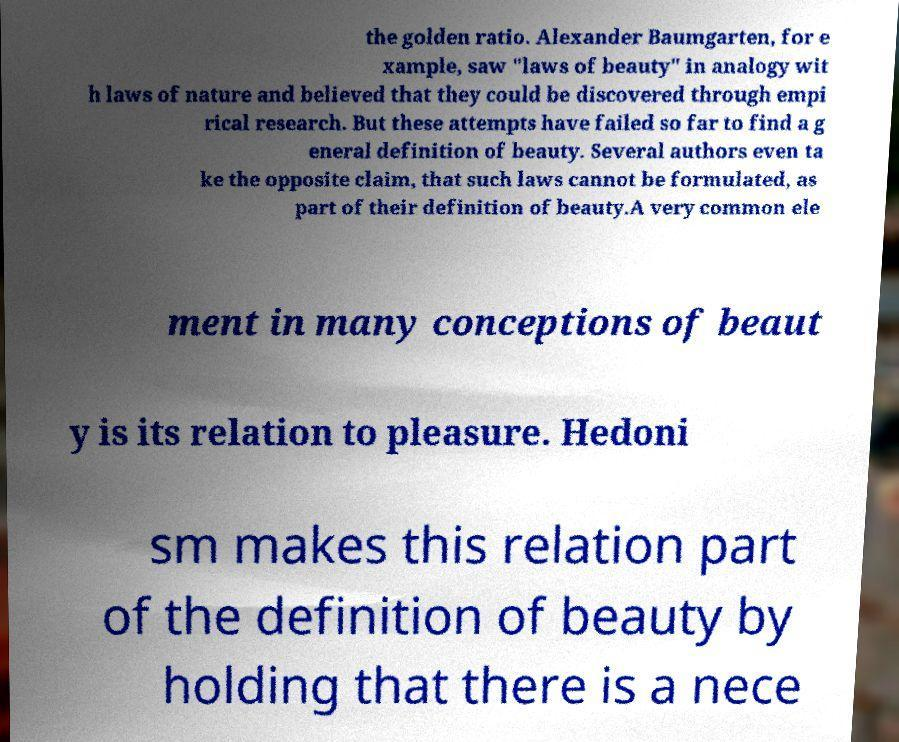There's text embedded in this image that I need extracted. Can you transcribe it verbatim? the golden ratio. Alexander Baumgarten, for e xample, saw "laws of beauty" in analogy wit h laws of nature and believed that they could be discovered through empi rical research. But these attempts have failed so far to find a g eneral definition of beauty. Several authors even ta ke the opposite claim, that such laws cannot be formulated, as part of their definition of beauty.A very common ele ment in many conceptions of beaut y is its relation to pleasure. Hedoni sm makes this relation part of the definition of beauty by holding that there is a nece 